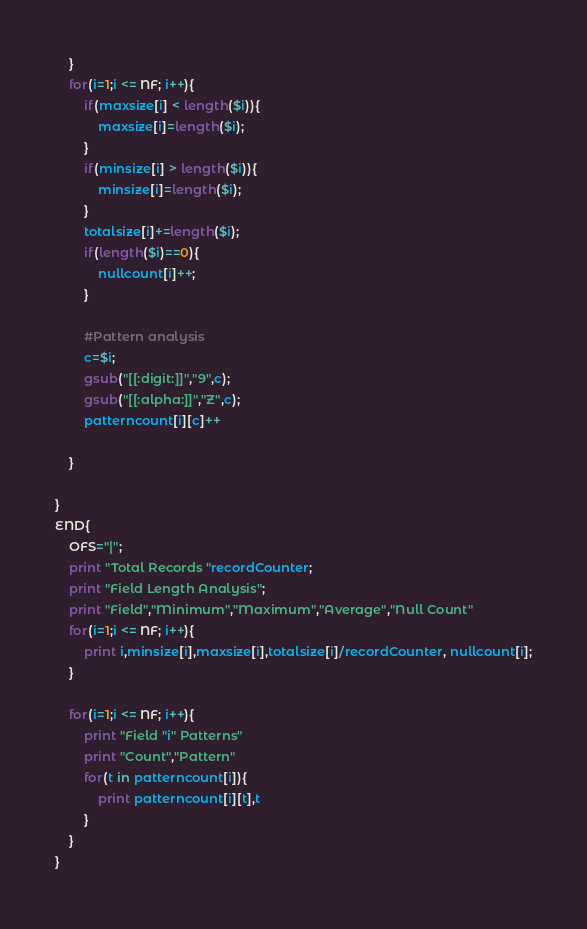Convert code to text. <code><loc_0><loc_0><loc_500><loc_500><_Awk_>	}
	for(i=1;i <= NF; i++){
		if(maxsize[i] < length($i)){
			maxsize[i]=length($i);
		}
		if(minsize[i] > length($i)){
			minsize[i]=length($i);
		}
		totalsize[i]+=length($i);
		if(length($i)==0){
			nullcount[i]++;
		}
		
		#Pattern analysis
		c=$i;
		gsub("[[:digit:]]","9",c);
		gsub("[[:alpha:]]","Z",c);
		patterncount[i][c]++
		
	}
	
}
END{
	OFS="|";
	print "Total Records "recordCounter;
	print "Field Length Analysis";
	print "Field","Minimum","Maximum","Average","Null Count"
	for(i=1;i <= NF; i++){
		print i,minsize[i],maxsize[i],totalsize[i]/recordCounter, nullcount[i];
	}
	
	for(i=1;i <= NF; i++){
		print "Field "i" Patterns"
		print "Count","Pattern"
		for(t in patterncount[i]){
			print patterncount[i][t],t
		}
	}
}</code> 